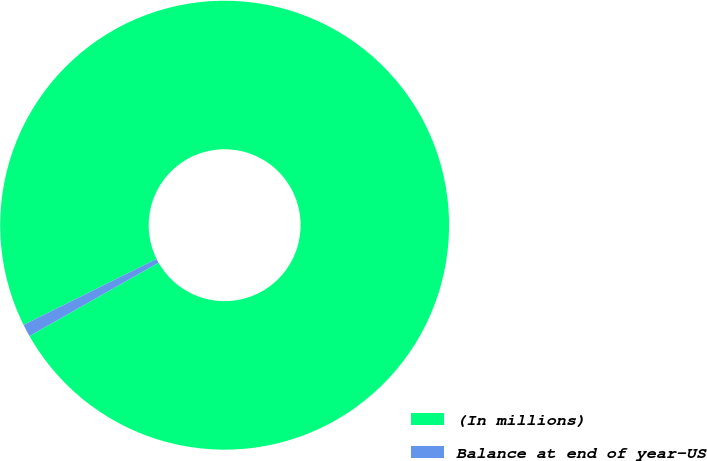Convert chart. <chart><loc_0><loc_0><loc_500><loc_500><pie_chart><fcel>(In millions)<fcel>Balance at end of year-US<nl><fcel>99.11%<fcel>0.89%<nl></chart> 